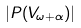<formula> <loc_0><loc_0><loc_500><loc_500>| P ( V _ { \omega + \alpha } ) |</formula> 